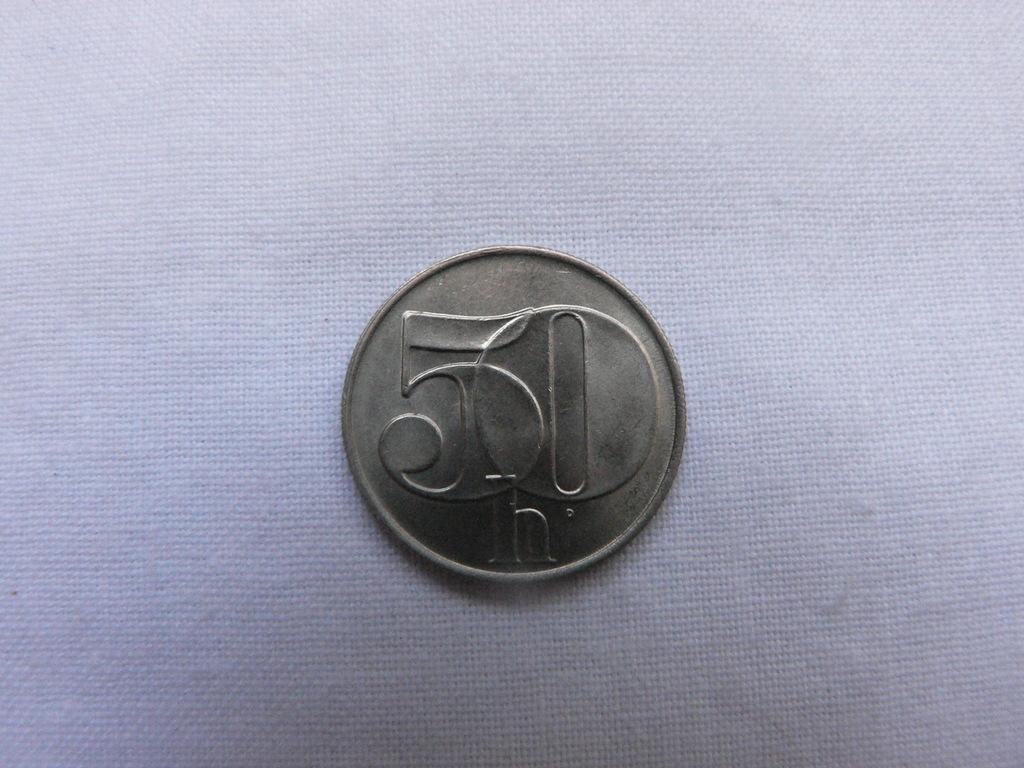<image>
Offer a succinct explanation of the picture presented. A coin on a table with 50 written on it. 